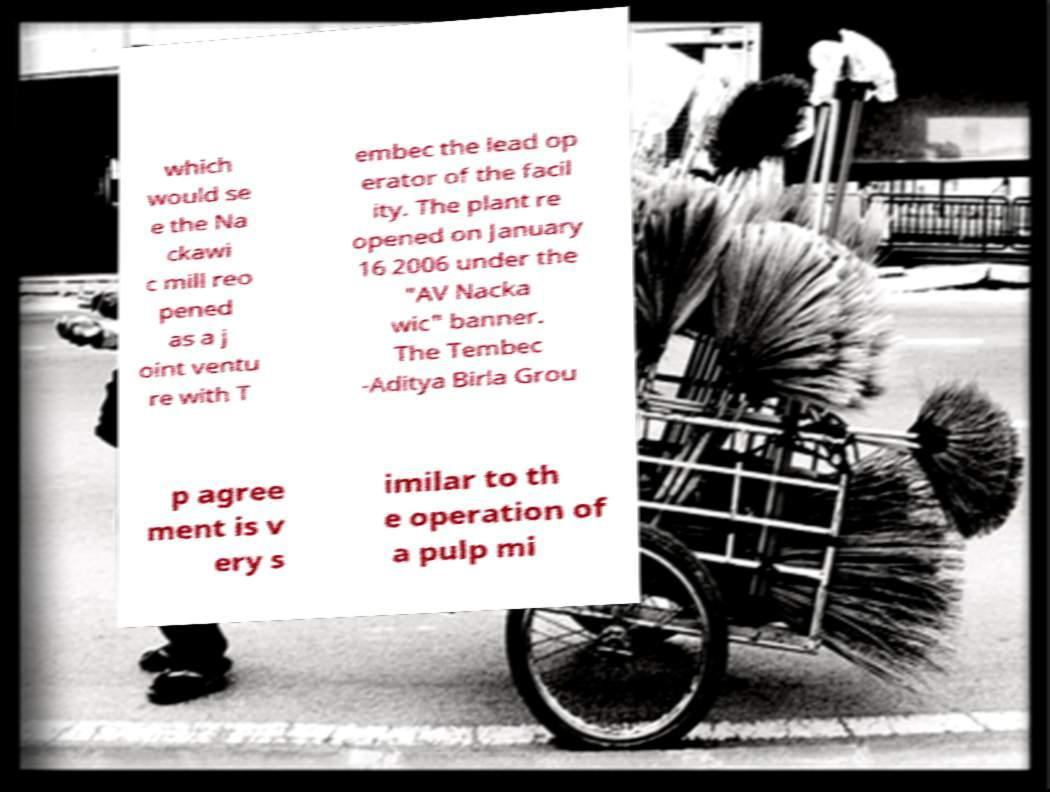I need the written content from this picture converted into text. Can you do that? which would se e the Na ckawi c mill reo pened as a j oint ventu re with T embec the lead op erator of the facil ity. The plant re opened on January 16 2006 under the "AV Nacka wic" banner. The Tembec -Aditya Birla Grou p agree ment is v ery s imilar to th e operation of a pulp mi 